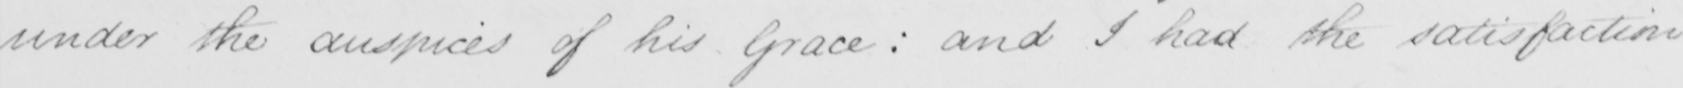Please transcribe the handwritten text in this image. under the auspice of his Grace :  and I had the satisfaction 